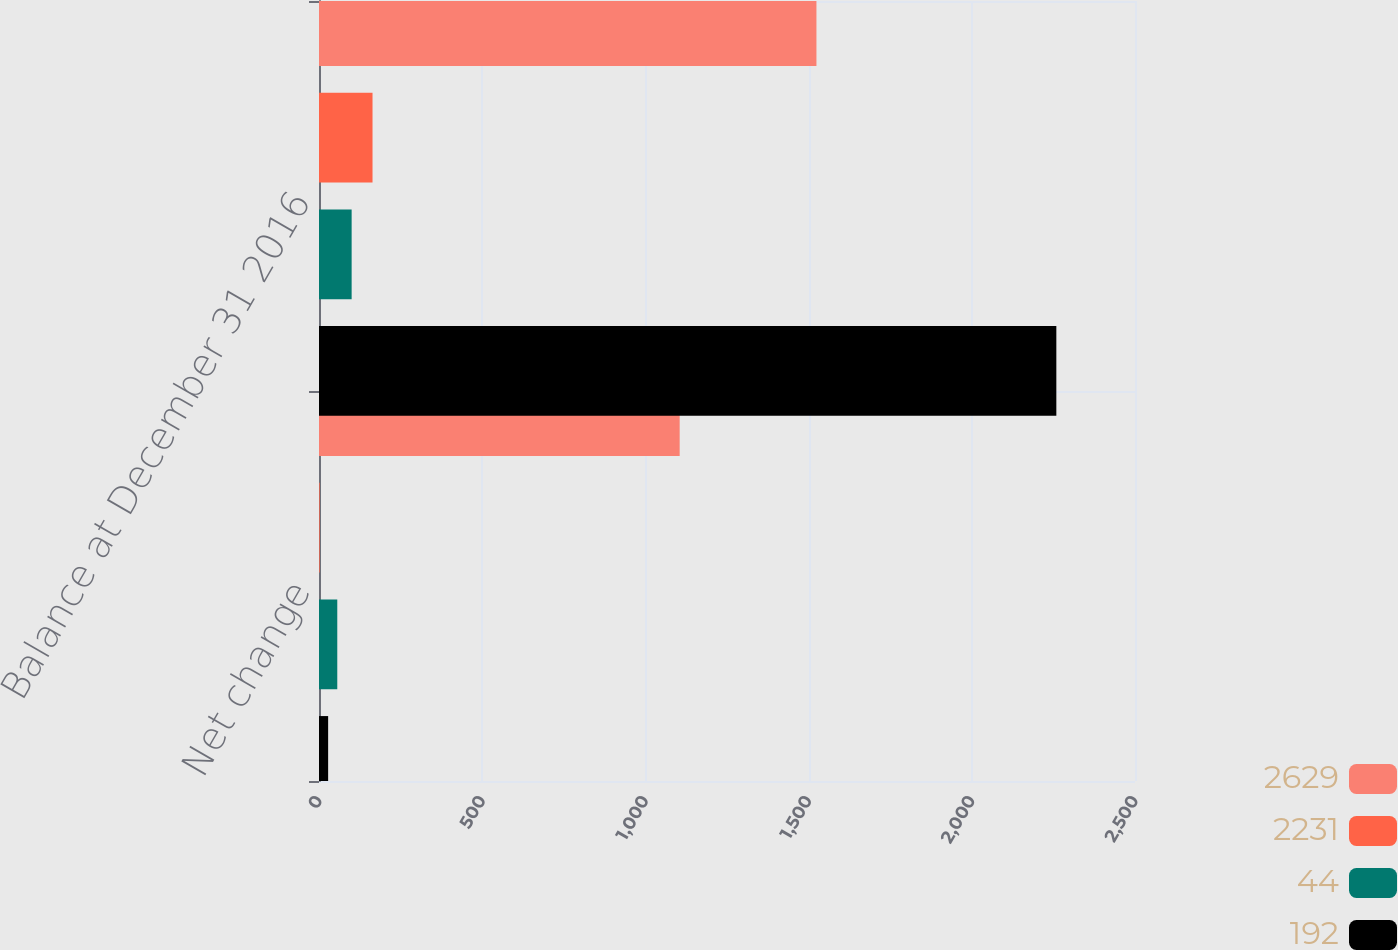Convert chart to OTSL. <chart><loc_0><loc_0><loc_500><loc_500><stacked_bar_chart><ecel><fcel>Net change<fcel>Balance at December 31 2016<nl><fcel>2629<fcel>1105<fcel>1524<nl><fcel>2231<fcel>2<fcel>164<nl><fcel>44<fcel>56<fcel>100<nl><fcel>192<fcel>28<fcel>2259<nl></chart> 